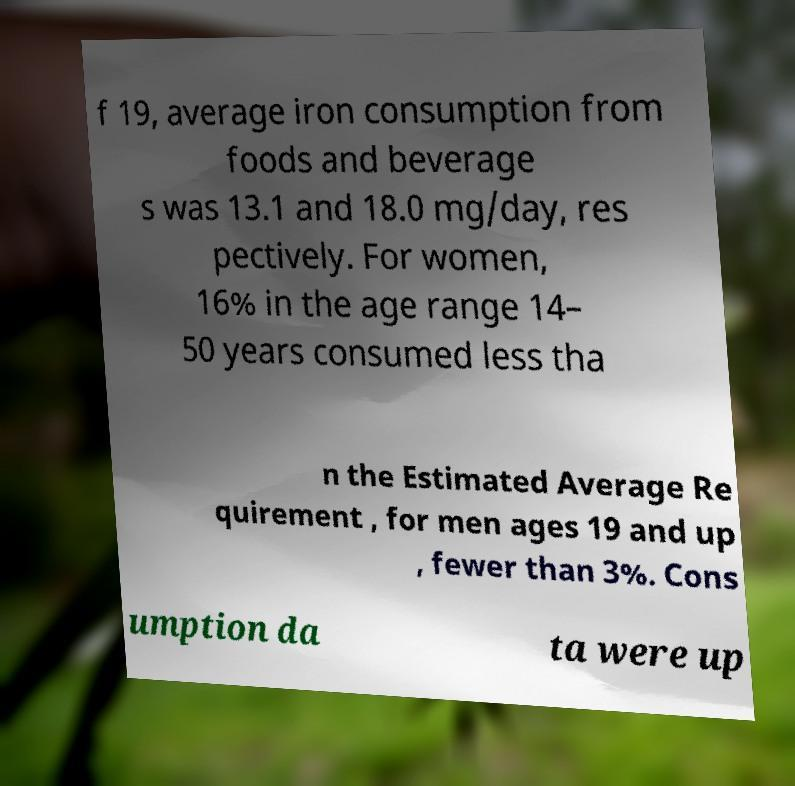Could you assist in decoding the text presented in this image and type it out clearly? f 19, average iron consumption from foods and beverage s was 13.1 and 18.0 mg/day, res pectively. For women, 16% in the age range 14– 50 years consumed less tha n the Estimated Average Re quirement , for men ages 19 and up , fewer than 3%. Cons umption da ta were up 